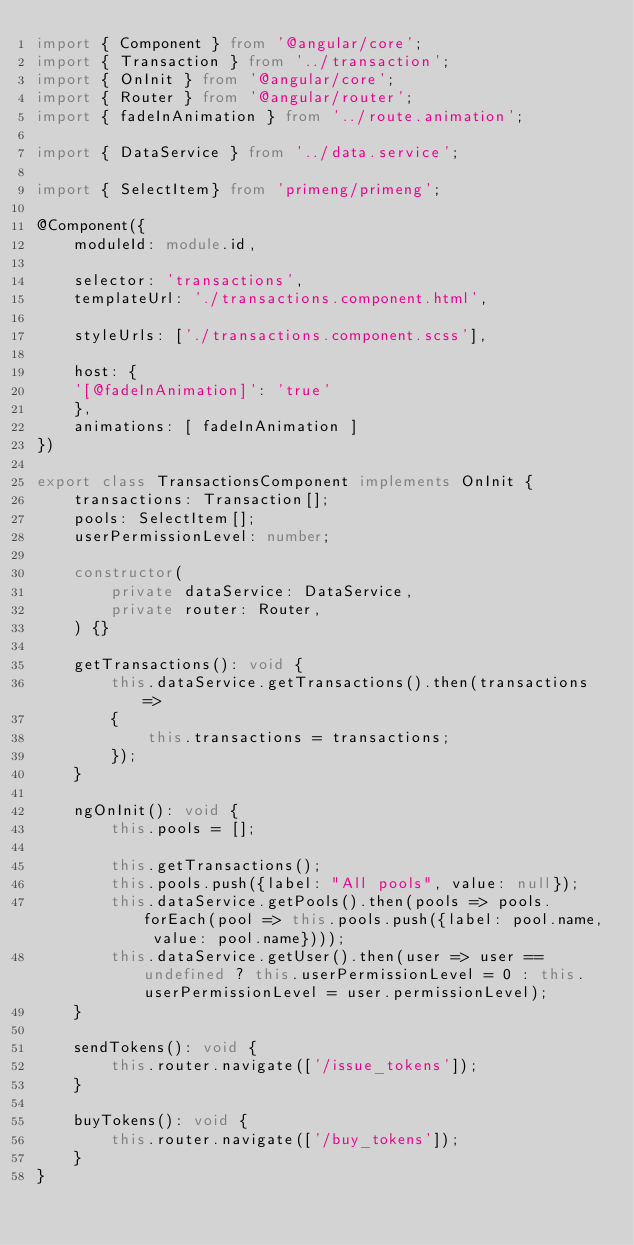<code> <loc_0><loc_0><loc_500><loc_500><_TypeScript_>import { Component } from '@angular/core';
import { Transaction } from '../transaction';
import { OnInit } from '@angular/core';
import { Router } from '@angular/router';
import { fadeInAnimation } from '../route.animation';

import { DataService } from '../data.service';

import { SelectItem} from 'primeng/primeng';

@Component({
	moduleId: module.id,
	
	selector: 'transactions',
	templateUrl: './transactions.component.html',
	
	styleUrls: ['./transactions.component.scss'],

	host: {
    '[@fadeInAnimation]': 'true'
	},
	animations: [ fadeInAnimation ]
})

export class TransactionsComponent implements OnInit {
    transactions: Transaction[];
	pools: SelectItem[];
	userPermissionLevel: number;

	constructor(
		private dataService: DataService,
		private router: Router,
	) {}
	
	getTransactions(): void {
		this.dataService.getTransactions().then(transactions =>
		{
            this.transactions = transactions;
		});
	}

	ngOnInit(): void {
		this.pools = [];

		this.getTransactions();
		this.pools.push({label: "All pools", value: null});
		this.dataService.getPools().then(pools => pools.forEach(pool => this.pools.push({label: pool.name, value: pool.name})));
		this.dataService.getUser().then(user => user == undefined ? this.userPermissionLevel = 0 : this.userPermissionLevel = user.permissionLevel);
    }

	sendTokens(): void {
		this.router.navigate(['/issue_tokens']);
	}

	buyTokens(): void {
		this.router.navigate(['/buy_tokens']);
	}
}</code> 